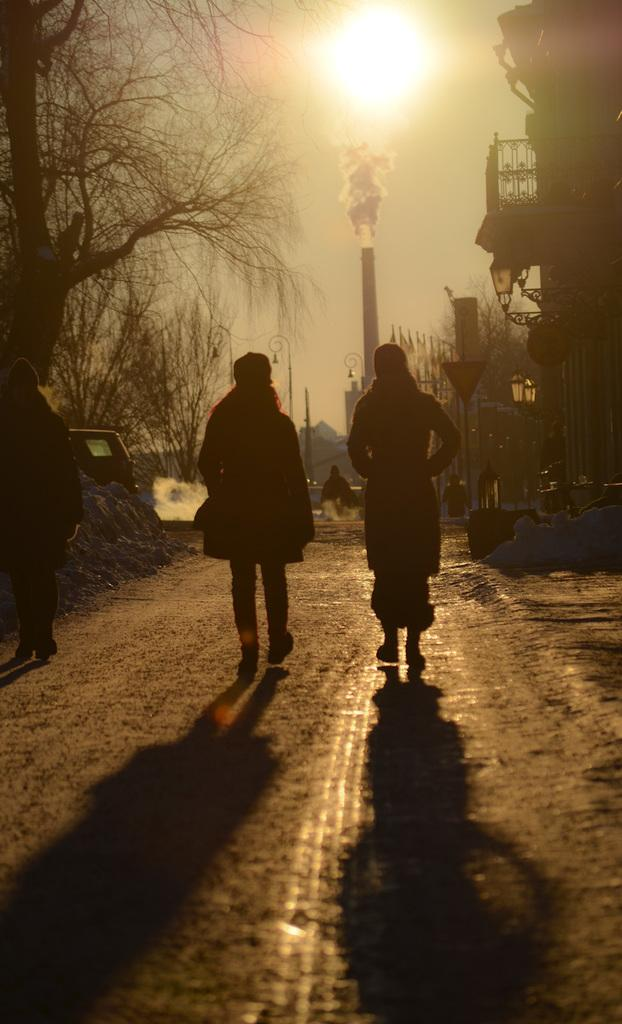What are the people in the image doing? The people in the image are walking on the road. What type of vegetation can be seen in the image? There are trees in the image. What structures are present in the image? There are poles and a building in the image. What can be seen coming from the building in the image? There is smoke visible in the image. What is visible in the background of the image? The sky is visible in the background of the image. What type of oil can be seen dripping from the trees in the image? There is no oil present in the image; it features people walking on the road, trees, poles, a building, smoke, and the sky. What is the reaction of the people to the lip in the image? There is no lip present in the image, so it is not possible to determine any reactions from the people. 